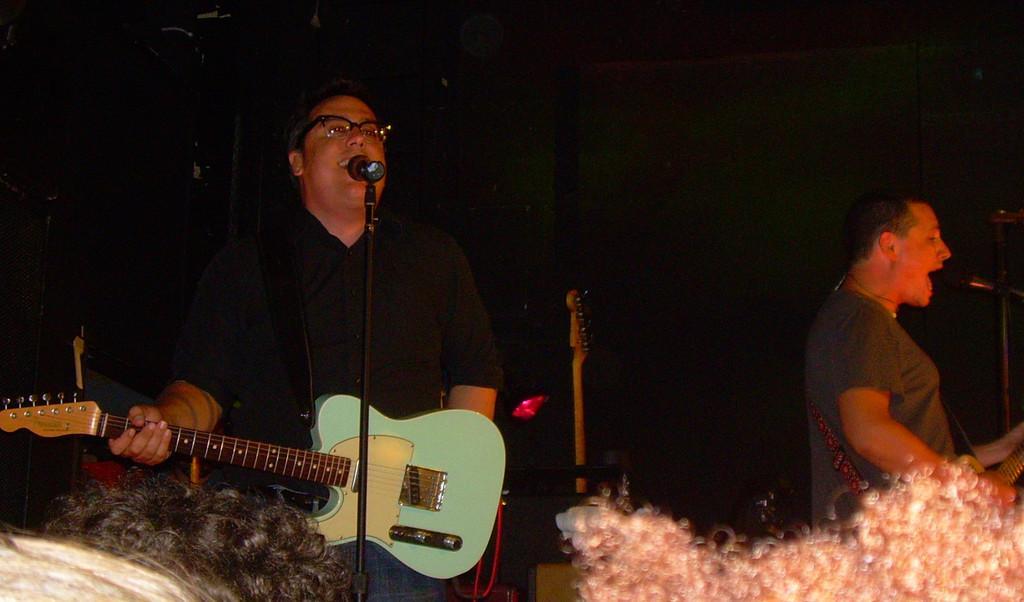What is the person in the foreground of the image holding? The person in the foreground of the image is holding a guitar. What object is in front of the person holding the guitar? There is a microphone in front of the person holding the guitar. Can you describe the person in the background of the image? The person in the background of the image is holding a musical instrument. What type of pin can be seen in the scene? There is no pin present in the image; it features two people with musical instruments and a microphone. 